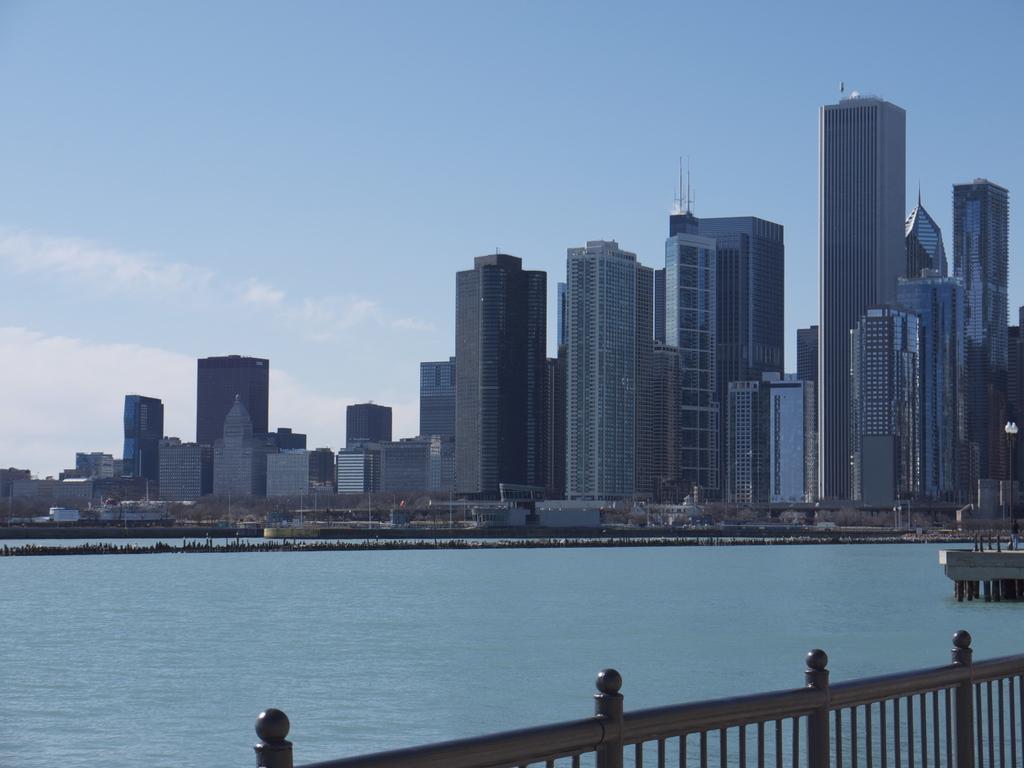Can you describe this image briefly? In this image we can see a group of buildings. In front of the building we can see trees, poles and the water. At the bottom we can see metal railing. At the top we can see the clear sky. 